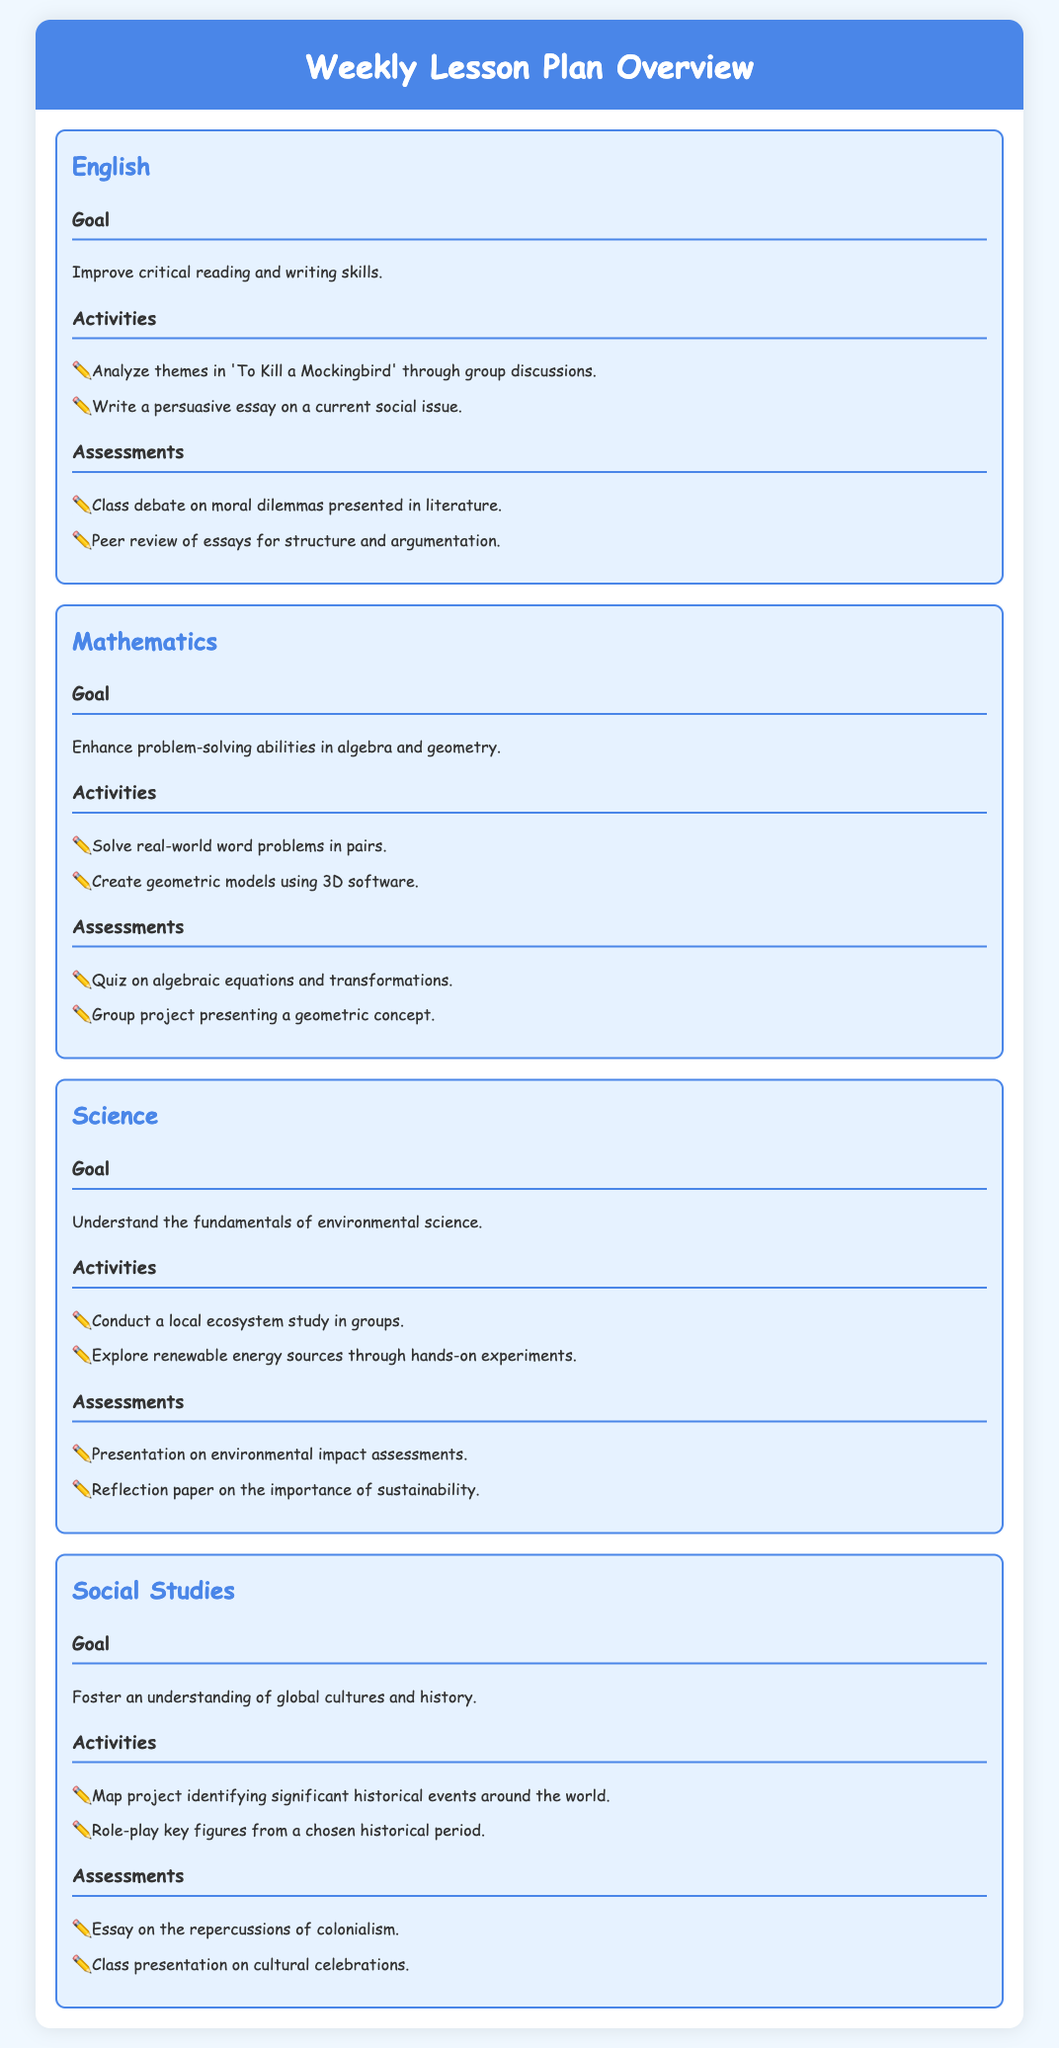What is the goal of the English lesson? The goal is to improve critical reading and writing skills.
Answer: Improve critical reading and writing skills What is one assessment method for the Science subject? One method is a presentation on environmental impact assessments.
Answer: Presentation on environmental impact assessments Which activity is suggested for Mathematics? The activity involves solving real-world word problems in pairs.
Answer: Solve real-world word problems in pairs How many subjects are covered in the lesson plan? The document presents four subjects: English, Mathematics, Science, and Social Studies.
Answer: Four What is the goal of the Social Studies subject? The goal is to foster an understanding of global cultures and history.
Answer: Foster an understanding of global cultures and history What type of essay is assigned in the English lessons? Students are assigned to write a persuasive essay on a current social issue.
Answer: Persuasive essay on a current social issue Which geometric activity utilizes technology? The activity involves creating geometric models using 3D software.
Answer: Create geometric models using 3D software What is a key activity for the Science lesson? A key activity is conducting a local ecosystem study in groups.
Answer: Conduct a local ecosystem study in groups What type of project is included in the Mathematics assessments? A group project presenting a geometric concept is included.
Answer: Group project presenting a geometric concept 